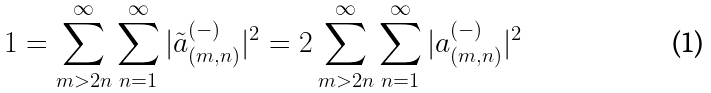Convert formula to latex. <formula><loc_0><loc_0><loc_500><loc_500>1 = \sum _ { m > 2 n } ^ { \infty } \sum _ { n = 1 } ^ { \infty } | \tilde { a } _ { ( m , n ) } ^ { ( - ) } | ^ { 2 } = 2 \sum _ { m > 2 n } ^ { \infty } \sum _ { n = 1 } ^ { \infty } | a _ { ( m , n ) } ^ { ( - ) } | ^ { 2 }</formula> 